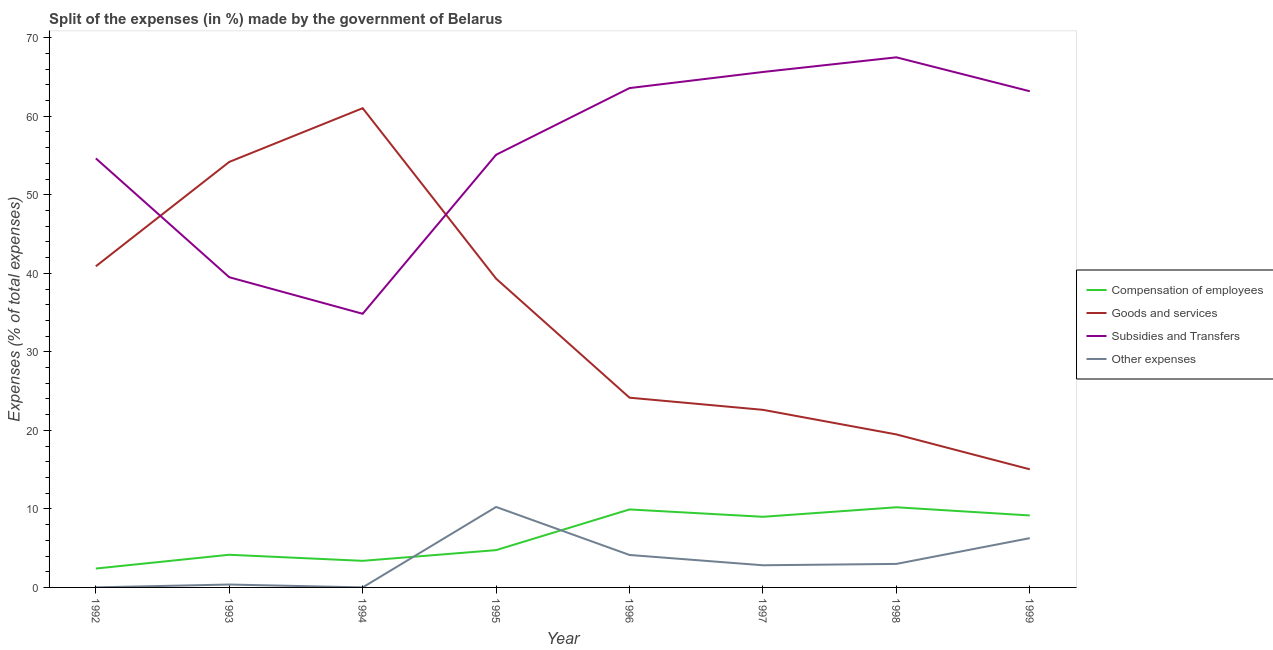How many different coloured lines are there?
Offer a terse response. 4. Does the line corresponding to percentage of amount spent on other expenses intersect with the line corresponding to percentage of amount spent on goods and services?
Provide a succinct answer. No. Is the number of lines equal to the number of legend labels?
Give a very brief answer. Yes. What is the percentage of amount spent on subsidies in 1998?
Provide a short and direct response. 67.51. Across all years, what is the maximum percentage of amount spent on compensation of employees?
Your answer should be compact. 10.21. Across all years, what is the minimum percentage of amount spent on other expenses?
Make the answer very short. 0. In which year was the percentage of amount spent on other expenses maximum?
Give a very brief answer. 1995. In which year was the percentage of amount spent on goods and services minimum?
Your answer should be very brief. 1999. What is the total percentage of amount spent on other expenses in the graph?
Your answer should be compact. 26.86. What is the difference between the percentage of amount spent on subsidies in 1996 and that in 1999?
Your answer should be very brief. 0.4. What is the difference between the percentage of amount spent on other expenses in 1999 and the percentage of amount spent on goods and services in 1996?
Give a very brief answer. -17.89. What is the average percentage of amount spent on subsidies per year?
Give a very brief answer. 55.5. In the year 1995, what is the difference between the percentage of amount spent on other expenses and percentage of amount spent on goods and services?
Your response must be concise. -29.07. In how many years, is the percentage of amount spent on subsidies greater than 26 %?
Offer a very short reply. 8. What is the ratio of the percentage of amount spent on other expenses in 1992 to that in 1997?
Provide a short and direct response. 0. Is the difference between the percentage of amount spent on subsidies in 1995 and 1998 greater than the difference between the percentage of amount spent on compensation of employees in 1995 and 1998?
Provide a short and direct response. No. What is the difference between the highest and the second highest percentage of amount spent on other expenses?
Provide a short and direct response. 3.97. What is the difference between the highest and the lowest percentage of amount spent on other expenses?
Make the answer very short. 10.24. Is it the case that in every year, the sum of the percentage of amount spent on subsidies and percentage of amount spent on compensation of employees is greater than the sum of percentage of amount spent on other expenses and percentage of amount spent on goods and services?
Your response must be concise. Yes. Is it the case that in every year, the sum of the percentage of amount spent on compensation of employees and percentage of amount spent on goods and services is greater than the percentage of amount spent on subsidies?
Give a very brief answer. No. Does the percentage of amount spent on goods and services monotonically increase over the years?
Your answer should be very brief. No. Is the percentage of amount spent on compensation of employees strictly greater than the percentage of amount spent on other expenses over the years?
Ensure brevity in your answer.  No. Is the percentage of amount spent on compensation of employees strictly less than the percentage of amount spent on other expenses over the years?
Make the answer very short. No. How many lines are there?
Keep it short and to the point. 4. Does the graph contain grids?
Your answer should be compact. No. Where does the legend appear in the graph?
Make the answer very short. Center right. How many legend labels are there?
Offer a terse response. 4. What is the title of the graph?
Your response must be concise. Split of the expenses (in %) made by the government of Belarus. Does "Quality Certification" appear as one of the legend labels in the graph?
Offer a terse response. No. What is the label or title of the Y-axis?
Your answer should be very brief. Expenses (% of total expenses). What is the Expenses (% of total expenses) in Compensation of employees in 1992?
Your response must be concise. 2.41. What is the Expenses (% of total expenses) of Goods and services in 1992?
Your response must be concise. 40.89. What is the Expenses (% of total expenses) of Subsidies and Transfers in 1992?
Your answer should be compact. 54.64. What is the Expenses (% of total expenses) of Other expenses in 1992?
Your answer should be very brief. 0.01. What is the Expenses (% of total expenses) of Compensation of employees in 1993?
Provide a succinct answer. 4.16. What is the Expenses (% of total expenses) in Goods and services in 1993?
Give a very brief answer. 54.19. What is the Expenses (% of total expenses) in Subsidies and Transfers in 1993?
Provide a short and direct response. 39.5. What is the Expenses (% of total expenses) of Other expenses in 1993?
Your answer should be very brief. 0.37. What is the Expenses (% of total expenses) in Compensation of employees in 1994?
Your response must be concise. 3.39. What is the Expenses (% of total expenses) in Goods and services in 1994?
Your response must be concise. 61.03. What is the Expenses (% of total expenses) of Subsidies and Transfers in 1994?
Your answer should be very brief. 34.85. What is the Expenses (% of total expenses) of Other expenses in 1994?
Your answer should be compact. 0. What is the Expenses (% of total expenses) in Compensation of employees in 1995?
Offer a very short reply. 4.75. What is the Expenses (% of total expenses) of Goods and services in 1995?
Provide a succinct answer. 39.32. What is the Expenses (% of total expenses) in Subsidies and Transfers in 1995?
Your response must be concise. 55.1. What is the Expenses (% of total expenses) in Other expenses in 1995?
Your response must be concise. 10.25. What is the Expenses (% of total expenses) of Compensation of employees in 1996?
Your response must be concise. 9.93. What is the Expenses (% of total expenses) of Goods and services in 1996?
Your answer should be very brief. 24.16. What is the Expenses (% of total expenses) of Subsidies and Transfers in 1996?
Your response must be concise. 63.59. What is the Expenses (% of total expenses) of Other expenses in 1996?
Give a very brief answer. 4.13. What is the Expenses (% of total expenses) of Compensation of employees in 1997?
Offer a very short reply. 8.99. What is the Expenses (% of total expenses) of Goods and services in 1997?
Your answer should be compact. 22.62. What is the Expenses (% of total expenses) of Subsidies and Transfers in 1997?
Keep it short and to the point. 65.64. What is the Expenses (% of total expenses) of Other expenses in 1997?
Give a very brief answer. 2.82. What is the Expenses (% of total expenses) of Compensation of employees in 1998?
Offer a very short reply. 10.21. What is the Expenses (% of total expenses) of Goods and services in 1998?
Offer a terse response. 19.49. What is the Expenses (% of total expenses) of Subsidies and Transfers in 1998?
Give a very brief answer. 67.51. What is the Expenses (% of total expenses) of Other expenses in 1998?
Ensure brevity in your answer.  2.99. What is the Expenses (% of total expenses) of Compensation of employees in 1999?
Provide a short and direct response. 9.17. What is the Expenses (% of total expenses) in Goods and services in 1999?
Your answer should be very brief. 15.04. What is the Expenses (% of total expenses) in Subsidies and Transfers in 1999?
Your answer should be compact. 63.19. What is the Expenses (% of total expenses) of Other expenses in 1999?
Your response must be concise. 6.28. Across all years, what is the maximum Expenses (% of total expenses) of Compensation of employees?
Give a very brief answer. 10.21. Across all years, what is the maximum Expenses (% of total expenses) of Goods and services?
Your answer should be very brief. 61.03. Across all years, what is the maximum Expenses (% of total expenses) in Subsidies and Transfers?
Ensure brevity in your answer.  67.51. Across all years, what is the maximum Expenses (% of total expenses) of Other expenses?
Make the answer very short. 10.25. Across all years, what is the minimum Expenses (% of total expenses) of Compensation of employees?
Ensure brevity in your answer.  2.41. Across all years, what is the minimum Expenses (% of total expenses) in Goods and services?
Ensure brevity in your answer.  15.04. Across all years, what is the minimum Expenses (% of total expenses) of Subsidies and Transfers?
Your answer should be very brief. 34.85. Across all years, what is the minimum Expenses (% of total expenses) in Other expenses?
Ensure brevity in your answer.  0. What is the total Expenses (% of total expenses) in Compensation of employees in the graph?
Give a very brief answer. 53. What is the total Expenses (% of total expenses) of Goods and services in the graph?
Give a very brief answer. 276.73. What is the total Expenses (% of total expenses) in Subsidies and Transfers in the graph?
Provide a short and direct response. 444.02. What is the total Expenses (% of total expenses) of Other expenses in the graph?
Make the answer very short. 26.86. What is the difference between the Expenses (% of total expenses) in Compensation of employees in 1992 and that in 1993?
Provide a succinct answer. -1.75. What is the difference between the Expenses (% of total expenses) of Goods and services in 1992 and that in 1993?
Make the answer very short. -13.29. What is the difference between the Expenses (% of total expenses) in Subsidies and Transfers in 1992 and that in 1993?
Provide a succinct answer. 15.14. What is the difference between the Expenses (% of total expenses) in Other expenses in 1992 and that in 1993?
Provide a succinct answer. -0.36. What is the difference between the Expenses (% of total expenses) of Compensation of employees in 1992 and that in 1994?
Ensure brevity in your answer.  -0.98. What is the difference between the Expenses (% of total expenses) of Goods and services in 1992 and that in 1994?
Your response must be concise. -20.14. What is the difference between the Expenses (% of total expenses) of Subsidies and Transfers in 1992 and that in 1994?
Ensure brevity in your answer.  19.79. What is the difference between the Expenses (% of total expenses) of Other expenses in 1992 and that in 1994?
Your response must be concise. 0.01. What is the difference between the Expenses (% of total expenses) in Compensation of employees in 1992 and that in 1995?
Your answer should be compact. -2.35. What is the difference between the Expenses (% of total expenses) of Goods and services in 1992 and that in 1995?
Keep it short and to the point. 1.57. What is the difference between the Expenses (% of total expenses) of Subsidies and Transfers in 1992 and that in 1995?
Your response must be concise. -0.46. What is the difference between the Expenses (% of total expenses) in Other expenses in 1992 and that in 1995?
Make the answer very short. -10.24. What is the difference between the Expenses (% of total expenses) in Compensation of employees in 1992 and that in 1996?
Your answer should be compact. -7.53. What is the difference between the Expenses (% of total expenses) of Goods and services in 1992 and that in 1996?
Ensure brevity in your answer.  16.73. What is the difference between the Expenses (% of total expenses) in Subsidies and Transfers in 1992 and that in 1996?
Provide a short and direct response. -8.95. What is the difference between the Expenses (% of total expenses) in Other expenses in 1992 and that in 1996?
Keep it short and to the point. -4.12. What is the difference between the Expenses (% of total expenses) of Compensation of employees in 1992 and that in 1997?
Make the answer very short. -6.59. What is the difference between the Expenses (% of total expenses) in Goods and services in 1992 and that in 1997?
Ensure brevity in your answer.  18.28. What is the difference between the Expenses (% of total expenses) of Subsidies and Transfers in 1992 and that in 1997?
Provide a short and direct response. -11. What is the difference between the Expenses (% of total expenses) in Other expenses in 1992 and that in 1997?
Your response must be concise. -2.81. What is the difference between the Expenses (% of total expenses) of Compensation of employees in 1992 and that in 1998?
Keep it short and to the point. -7.8. What is the difference between the Expenses (% of total expenses) of Goods and services in 1992 and that in 1998?
Provide a short and direct response. 21.41. What is the difference between the Expenses (% of total expenses) in Subsidies and Transfers in 1992 and that in 1998?
Provide a short and direct response. -12.87. What is the difference between the Expenses (% of total expenses) of Other expenses in 1992 and that in 1998?
Make the answer very short. -2.99. What is the difference between the Expenses (% of total expenses) in Compensation of employees in 1992 and that in 1999?
Make the answer very short. -6.76. What is the difference between the Expenses (% of total expenses) in Goods and services in 1992 and that in 1999?
Your answer should be very brief. 25.85. What is the difference between the Expenses (% of total expenses) of Subsidies and Transfers in 1992 and that in 1999?
Keep it short and to the point. -8.55. What is the difference between the Expenses (% of total expenses) of Other expenses in 1992 and that in 1999?
Provide a short and direct response. -6.27. What is the difference between the Expenses (% of total expenses) in Compensation of employees in 1993 and that in 1994?
Offer a very short reply. 0.77. What is the difference between the Expenses (% of total expenses) in Goods and services in 1993 and that in 1994?
Provide a short and direct response. -6.84. What is the difference between the Expenses (% of total expenses) of Subsidies and Transfers in 1993 and that in 1994?
Offer a very short reply. 4.65. What is the difference between the Expenses (% of total expenses) of Other expenses in 1993 and that in 1994?
Your answer should be very brief. 0.37. What is the difference between the Expenses (% of total expenses) of Compensation of employees in 1993 and that in 1995?
Offer a terse response. -0.59. What is the difference between the Expenses (% of total expenses) in Goods and services in 1993 and that in 1995?
Keep it short and to the point. 14.87. What is the difference between the Expenses (% of total expenses) in Subsidies and Transfers in 1993 and that in 1995?
Provide a short and direct response. -15.6. What is the difference between the Expenses (% of total expenses) of Other expenses in 1993 and that in 1995?
Offer a terse response. -9.88. What is the difference between the Expenses (% of total expenses) in Compensation of employees in 1993 and that in 1996?
Provide a succinct answer. -5.77. What is the difference between the Expenses (% of total expenses) of Goods and services in 1993 and that in 1996?
Offer a very short reply. 30.03. What is the difference between the Expenses (% of total expenses) in Subsidies and Transfers in 1993 and that in 1996?
Give a very brief answer. -24.09. What is the difference between the Expenses (% of total expenses) of Other expenses in 1993 and that in 1996?
Offer a very short reply. -3.76. What is the difference between the Expenses (% of total expenses) in Compensation of employees in 1993 and that in 1997?
Offer a very short reply. -4.83. What is the difference between the Expenses (% of total expenses) of Goods and services in 1993 and that in 1997?
Offer a very short reply. 31.57. What is the difference between the Expenses (% of total expenses) of Subsidies and Transfers in 1993 and that in 1997?
Offer a very short reply. -26.14. What is the difference between the Expenses (% of total expenses) in Other expenses in 1993 and that in 1997?
Keep it short and to the point. -2.45. What is the difference between the Expenses (% of total expenses) in Compensation of employees in 1993 and that in 1998?
Your response must be concise. -6.05. What is the difference between the Expenses (% of total expenses) in Goods and services in 1993 and that in 1998?
Offer a very short reply. 34.7. What is the difference between the Expenses (% of total expenses) in Subsidies and Transfers in 1993 and that in 1998?
Your answer should be very brief. -28. What is the difference between the Expenses (% of total expenses) of Other expenses in 1993 and that in 1998?
Provide a short and direct response. -2.63. What is the difference between the Expenses (% of total expenses) of Compensation of employees in 1993 and that in 1999?
Your answer should be very brief. -5.01. What is the difference between the Expenses (% of total expenses) of Goods and services in 1993 and that in 1999?
Your answer should be very brief. 39.15. What is the difference between the Expenses (% of total expenses) of Subsidies and Transfers in 1993 and that in 1999?
Your response must be concise. -23.68. What is the difference between the Expenses (% of total expenses) in Other expenses in 1993 and that in 1999?
Keep it short and to the point. -5.91. What is the difference between the Expenses (% of total expenses) in Compensation of employees in 1994 and that in 1995?
Give a very brief answer. -1.36. What is the difference between the Expenses (% of total expenses) of Goods and services in 1994 and that in 1995?
Ensure brevity in your answer.  21.71. What is the difference between the Expenses (% of total expenses) of Subsidies and Transfers in 1994 and that in 1995?
Your response must be concise. -20.25. What is the difference between the Expenses (% of total expenses) of Other expenses in 1994 and that in 1995?
Provide a short and direct response. -10.24. What is the difference between the Expenses (% of total expenses) in Compensation of employees in 1994 and that in 1996?
Your response must be concise. -6.54. What is the difference between the Expenses (% of total expenses) in Goods and services in 1994 and that in 1996?
Provide a short and direct response. 36.87. What is the difference between the Expenses (% of total expenses) of Subsidies and Transfers in 1994 and that in 1996?
Make the answer very short. -28.74. What is the difference between the Expenses (% of total expenses) of Other expenses in 1994 and that in 1996?
Give a very brief answer. -4.13. What is the difference between the Expenses (% of total expenses) in Compensation of employees in 1994 and that in 1997?
Give a very brief answer. -5.61. What is the difference between the Expenses (% of total expenses) in Goods and services in 1994 and that in 1997?
Make the answer very short. 38.41. What is the difference between the Expenses (% of total expenses) in Subsidies and Transfers in 1994 and that in 1997?
Give a very brief answer. -30.79. What is the difference between the Expenses (% of total expenses) in Other expenses in 1994 and that in 1997?
Your response must be concise. -2.82. What is the difference between the Expenses (% of total expenses) in Compensation of employees in 1994 and that in 1998?
Offer a very short reply. -6.82. What is the difference between the Expenses (% of total expenses) of Goods and services in 1994 and that in 1998?
Ensure brevity in your answer.  41.54. What is the difference between the Expenses (% of total expenses) of Subsidies and Transfers in 1994 and that in 1998?
Offer a very short reply. -32.66. What is the difference between the Expenses (% of total expenses) in Other expenses in 1994 and that in 1998?
Provide a short and direct response. -2.99. What is the difference between the Expenses (% of total expenses) in Compensation of employees in 1994 and that in 1999?
Keep it short and to the point. -5.78. What is the difference between the Expenses (% of total expenses) of Goods and services in 1994 and that in 1999?
Offer a terse response. 45.99. What is the difference between the Expenses (% of total expenses) in Subsidies and Transfers in 1994 and that in 1999?
Offer a terse response. -28.34. What is the difference between the Expenses (% of total expenses) of Other expenses in 1994 and that in 1999?
Keep it short and to the point. -6.27. What is the difference between the Expenses (% of total expenses) in Compensation of employees in 1995 and that in 1996?
Ensure brevity in your answer.  -5.18. What is the difference between the Expenses (% of total expenses) in Goods and services in 1995 and that in 1996?
Ensure brevity in your answer.  15.16. What is the difference between the Expenses (% of total expenses) of Subsidies and Transfers in 1995 and that in 1996?
Ensure brevity in your answer.  -8.49. What is the difference between the Expenses (% of total expenses) of Other expenses in 1995 and that in 1996?
Offer a terse response. 6.11. What is the difference between the Expenses (% of total expenses) of Compensation of employees in 1995 and that in 1997?
Give a very brief answer. -4.24. What is the difference between the Expenses (% of total expenses) of Goods and services in 1995 and that in 1997?
Offer a very short reply. 16.7. What is the difference between the Expenses (% of total expenses) of Subsidies and Transfers in 1995 and that in 1997?
Give a very brief answer. -10.54. What is the difference between the Expenses (% of total expenses) of Other expenses in 1995 and that in 1997?
Keep it short and to the point. 7.43. What is the difference between the Expenses (% of total expenses) of Compensation of employees in 1995 and that in 1998?
Your answer should be very brief. -5.46. What is the difference between the Expenses (% of total expenses) in Goods and services in 1995 and that in 1998?
Offer a terse response. 19.83. What is the difference between the Expenses (% of total expenses) of Subsidies and Transfers in 1995 and that in 1998?
Make the answer very short. -12.41. What is the difference between the Expenses (% of total expenses) in Other expenses in 1995 and that in 1998?
Make the answer very short. 7.25. What is the difference between the Expenses (% of total expenses) of Compensation of employees in 1995 and that in 1999?
Offer a very short reply. -4.41. What is the difference between the Expenses (% of total expenses) of Goods and services in 1995 and that in 1999?
Make the answer very short. 24.28. What is the difference between the Expenses (% of total expenses) in Subsidies and Transfers in 1995 and that in 1999?
Offer a very short reply. -8.09. What is the difference between the Expenses (% of total expenses) of Other expenses in 1995 and that in 1999?
Your answer should be very brief. 3.97. What is the difference between the Expenses (% of total expenses) of Compensation of employees in 1996 and that in 1997?
Offer a very short reply. 0.94. What is the difference between the Expenses (% of total expenses) of Goods and services in 1996 and that in 1997?
Your answer should be compact. 1.55. What is the difference between the Expenses (% of total expenses) of Subsidies and Transfers in 1996 and that in 1997?
Your answer should be very brief. -2.05. What is the difference between the Expenses (% of total expenses) in Other expenses in 1996 and that in 1997?
Your answer should be compact. 1.31. What is the difference between the Expenses (% of total expenses) of Compensation of employees in 1996 and that in 1998?
Keep it short and to the point. -0.28. What is the difference between the Expenses (% of total expenses) in Goods and services in 1996 and that in 1998?
Your answer should be compact. 4.68. What is the difference between the Expenses (% of total expenses) of Subsidies and Transfers in 1996 and that in 1998?
Offer a very short reply. -3.92. What is the difference between the Expenses (% of total expenses) in Other expenses in 1996 and that in 1998?
Give a very brief answer. 1.14. What is the difference between the Expenses (% of total expenses) in Compensation of employees in 1996 and that in 1999?
Provide a short and direct response. 0.77. What is the difference between the Expenses (% of total expenses) in Goods and services in 1996 and that in 1999?
Make the answer very short. 9.12. What is the difference between the Expenses (% of total expenses) of Subsidies and Transfers in 1996 and that in 1999?
Give a very brief answer. 0.4. What is the difference between the Expenses (% of total expenses) of Other expenses in 1996 and that in 1999?
Make the answer very short. -2.14. What is the difference between the Expenses (% of total expenses) of Compensation of employees in 1997 and that in 1998?
Provide a succinct answer. -1.21. What is the difference between the Expenses (% of total expenses) of Goods and services in 1997 and that in 1998?
Make the answer very short. 3.13. What is the difference between the Expenses (% of total expenses) in Subsidies and Transfers in 1997 and that in 1998?
Your answer should be compact. -1.86. What is the difference between the Expenses (% of total expenses) of Other expenses in 1997 and that in 1998?
Keep it short and to the point. -0.17. What is the difference between the Expenses (% of total expenses) in Compensation of employees in 1997 and that in 1999?
Keep it short and to the point. -0.17. What is the difference between the Expenses (% of total expenses) of Goods and services in 1997 and that in 1999?
Give a very brief answer. 7.58. What is the difference between the Expenses (% of total expenses) of Subsidies and Transfers in 1997 and that in 1999?
Provide a succinct answer. 2.46. What is the difference between the Expenses (% of total expenses) of Other expenses in 1997 and that in 1999?
Give a very brief answer. -3.45. What is the difference between the Expenses (% of total expenses) of Compensation of employees in 1998 and that in 1999?
Your response must be concise. 1.04. What is the difference between the Expenses (% of total expenses) in Goods and services in 1998 and that in 1999?
Ensure brevity in your answer.  4.44. What is the difference between the Expenses (% of total expenses) of Subsidies and Transfers in 1998 and that in 1999?
Your answer should be compact. 4.32. What is the difference between the Expenses (% of total expenses) in Other expenses in 1998 and that in 1999?
Your response must be concise. -3.28. What is the difference between the Expenses (% of total expenses) of Compensation of employees in 1992 and the Expenses (% of total expenses) of Goods and services in 1993?
Provide a short and direct response. -51.78. What is the difference between the Expenses (% of total expenses) of Compensation of employees in 1992 and the Expenses (% of total expenses) of Subsidies and Transfers in 1993?
Offer a terse response. -37.1. What is the difference between the Expenses (% of total expenses) in Compensation of employees in 1992 and the Expenses (% of total expenses) in Other expenses in 1993?
Your response must be concise. 2.04. What is the difference between the Expenses (% of total expenses) in Goods and services in 1992 and the Expenses (% of total expenses) in Subsidies and Transfers in 1993?
Offer a terse response. 1.39. What is the difference between the Expenses (% of total expenses) of Goods and services in 1992 and the Expenses (% of total expenses) of Other expenses in 1993?
Provide a short and direct response. 40.52. What is the difference between the Expenses (% of total expenses) in Subsidies and Transfers in 1992 and the Expenses (% of total expenses) in Other expenses in 1993?
Your answer should be very brief. 54.27. What is the difference between the Expenses (% of total expenses) of Compensation of employees in 1992 and the Expenses (% of total expenses) of Goods and services in 1994?
Provide a short and direct response. -58.62. What is the difference between the Expenses (% of total expenses) in Compensation of employees in 1992 and the Expenses (% of total expenses) in Subsidies and Transfers in 1994?
Your answer should be compact. -32.44. What is the difference between the Expenses (% of total expenses) of Compensation of employees in 1992 and the Expenses (% of total expenses) of Other expenses in 1994?
Offer a terse response. 2.4. What is the difference between the Expenses (% of total expenses) of Goods and services in 1992 and the Expenses (% of total expenses) of Subsidies and Transfers in 1994?
Provide a short and direct response. 6.05. What is the difference between the Expenses (% of total expenses) of Goods and services in 1992 and the Expenses (% of total expenses) of Other expenses in 1994?
Offer a very short reply. 40.89. What is the difference between the Expenses (% of total expenses) of Subsidies and Transfers in 1992 and the Expenses (% of total expenses) of Other expenses in 1994?
Give a very brief answer. 54.63. What is the difference between the Expenses (% of total expenses) in Compensation of employees in 1992 and the Expenses (% of total expenses) in Goods and services in 1995?
Ensure brevity in your answer.  -36.91. What is the difference between the Expenses (% of total expenses) in Compensation of employees in 1992 and the Expenses (% of total expenses) in Subsidies and Transfers in 1995?
Keep it short and to the point. -52.7. What is the difference between the Expenses (% of total expenses) in Compensation of employees in 1992 and the Expenses (% of total expenses) in Other expenses in 1995?
Your response must be concise. -7.84. What is the difference between the Expenses (% of total expenses) in Goods and services in 1992 and the Expenses (% of total expenses) in Subsidies and Transfers in 1995?
Your response must be concise. -14.21. What is the difference between the Expenses (% of total expenses) in Goods and services in 1992 and the Expenses (% of total expenses) in Other expenses in 1995?
Offer a terse response. 30.65. What is the difference between the Expenses (% of total expenses) of Subsidies and Transfers in 1992 and the Expenses (% of total expenses) of Other expenses in 1995?
Provide a succinct answer. 44.39. What is the difference between the Expenses (% of total expenses) of Compensation of employees in 1992 and the Expenses (% of total expenses) of Goods and services in 1996?
Offer a very short reply. -21.76. What is the difference between the Expenses (% of total expenses) in Compensation of employees in 1992 and the Expenses (% of total expenses) in Subsidies and Transfers in 1996?
Keep it short and to the point. -61.19. What is the difference between the Expenses (% of total expenses) of Compensation of employees in 1992 and the Expenses (% of total expenses) of Other expenses in 1996?
Provide a succinct answer. -1.73. What is the difference between the Expenses (% of total expenses) in Goods and services in 1992 and the Expenses (% of total expenses) in Subsidies and Transfers in 1996?
Your answer should be compact. -22.7. What is the difference between the Expenses (% of total expenses) of Goods and services in 1992 and the Expenses (% of total expenses) of Other expenses in 1996?
Offer a very short reply. 36.76. What is the difference between the Expenses (% of total expenses) in Subsidies and Transfers in 1992 and the Expenses (% of total expenses) in Other expenses in 1996?
Provide a succinct answer. 50.51. What is the difference between the Expenses (% of total expenses) of Compensation of employees in 1992 and the Expenses (% of total expenses) of Goods and services in 1997?
Offer a terse response. -20.21. What is the difference between the Expenses (% of total expenses) in Compensation of employees in 1992 and the Expenses (% of total expenses) in Subsidies and Transfers in 1997?
Ensure brevity in your answer.  -63.24. What is the difference between the Expenses (% of total expenses) of Compensation of employees in 1992 and the Expenses (% of total expenses) of Other expenses in 1997?
Provide a succinct answer. -0.42. What is the difference between the Expenses (% of total expenses) in Goods and services in 1992 and the Expenses (% of total expenses) in Subsidies and Transfers in 1997?
Ensure brevity in your answer.  -24.75. What is the difference between the Expenses (% of total expenses) of Goods and services in 1992 and the Expenses (% of total expenses) of Other expenses in 1997?
Make the answer very short. 38.07. What is the difference between the Expenses (% of total expenses) in Subsidies and Transfers in 1992 and the Expenses (% of total expenses) in Other expenses in 1997?
Make the answer very short. 51.82. What is the difference between the Expenses (% of total expenses) of Compensation of employees in 1992 and the Expenses (% of total expenses) of Goods and services in 1998?
Give a very brief answer. -17.08. What is the difference between the Expenses (% of total expenses) of Compensation of employees in 1992 and the Expenses (% of total expenses) of Subsidies and Transfers in 1998?
Your answer should be compact. -65.1. What is the difference between the Expenses (% of total expenses) of Compensation of employees in 1992 and the Expenses (% of total expenses) of Other expenses in 1998?
Your answer should be compact. -0.59. What is the difference between the Expenses (% of total expenses) of Goods and services in 1992 and the Expenses (% of total expenses) of Subsidies and Transfers in 1998?
Make the answer very short. -26.61. What is the difference between the Expenses (% of total expenses) of Goods and services in 1992 and the Expenses (% of total expenses) of Other expenses in 1998?
Keep it short and to the point. 37.9. What is the difference between the Expenses (% of total expenses) in Subsidies and Transfers in 1992 and the Expenses (% of total expenses) in Other expenses in 1998?
Ensure brevity in your answer.  51.64. What is the difference between the Expenses (% of total expenses) of Compensation of employees in 1992 and the Expenses (% of total expenses) of Goods and services in 1999?
Your answer should be compact. -12.64. What is the difference between the Expenses (% of total expenses) of Compensation of employees in 1992 and the Expenses (% of total expenses) of Subsidies and Transfers in 1999?
Your answer should be compact. -60.78. What is the difference between the Expenses (% of total expenses) of Compensation of employees in 1992 and the Expenses (% of total expenses) of Other expenses in 1999?
Ensure brevity in your answer.  -3.87. What is the difference between the Expenses (% of total expenses) of Goods and services in 1992 and the Expenses (% of total expenses) of Subsidies and Transfers in 1999?
Make the answer very short. -22.29. What is the difference between the Expenses (% of total expenses) of Goods and services in 1992 and the Expenses (% of total expenses) of Other expenses in 1999?
Give a very brief answer. 34.62. What is the difference between the Expenses (% of total expenses) in Subsidies and Transfers in 1992 and the Expenses (% of total expenses) in Other expenses in 1999?
Ensure brevity in your answer.  48.36. What is the difference between the Expenses (% of total expenses) in Compensation of employees in 1993 and the Expenses (% of total expenses) in Goods and services in 1994?
Your answer should be very brief. -56.87. What is the difference between the Expenses (% of total expenses) in Compensation of employees in 1993 and the Expenses (% of total expenses) in Subsidies and Transfers in 1994?
Your answer should be very brief. -30.69. What is the difference between the Expenses (% of total expenses) in Compensation of employees in 1993 and the Expenses (% of total expenses) in Other expenses in 1994?
Your answer should be compact. 4.16. What is the difference between the Expenses (% of total expenses) of Goods and services in 1993 and the Expenses (% of total expenses) of Subsidies and Transfers in 1994?
Provide a short and direct response. 19.34. What is the difference between the Expenses (% of total expenses) in Goods and services in 1993 and the Expenses (% of total expenses) in Other expenses in 1994?
Offer a terse response. 54.18. What is the difference between the Expenses (% of total expenses) of Subsidies and Transfers in 1993 and the Expenses (% of total expenses) of Other expenses in 1994?
Offer a terse response. 39.5. What is the difference between the Expenses (% of total expenses) in Compensation of employees in 1993 and the Expenses (% of total expenses) in Goods and services in 1995?
Make the answer very short. -35.16. What is the difference between the Expenses (% of total expenses) of Compensation of employees in 1993 and the Expenses (% of total expenses) of Subsidies and Transfers in 1995?
Give a very brief answer. -50.94. What is the difference between the Expenses (% of total expenses) of Compensation of employees in 1993 and the Expenses (% of total expenses) of Other expenses in 1995?
Offer a terse response. -6.09. What is the difference between the Expenses (% of total expenses) in Goods and services in 1993 and the Expenses (% of total expenses) in Subsidies and Transfers in 1995?
Provide a succinct answer. -0.91. What is the difference between the Expenses (% of total expenses) of Goods and services in 1993 and the Expenses (% of total expenses) of Other expenses in 1995?
Provide a succinct answer. 43.94. What is the difference between the Expenses (% of total expenses) of Subsidies and Transfers in 1993 and the Expenses (% of total expenses) of Other expenses in 1995?
Provide a short and direct response. 29.26. What is the difference between the Expenses (% of total expenses) of Compensation of employees in 1993 and the Expenses (% of total expenses) of Goods and services in 1996?
Keep it short and to the point. -20. What is the difference between the Expenses (% of total expenses) of Compensation of employees in 1993 and the Expenses (% of total expenses) of Subsidies and Transfers in 1996?
Keep it short and to the point. -59.43. What is the difference between the Expenses (% of total expenses) of Compensation of employees in 1993 and the Expenses (% of total expenses) of Other expenses in 1996?
Give a very brief answer. 0.03. What is the difference between the Expenses (% of total expenses) of Goods and services in 1993 and the Expenses (% of total expenses) of Subsidies and Transfers in 1996?
Ensure brevity in your answer.  -9.4. What is the difference between the Expenses (% of total expenses) of Goods and services in 1993 and the Expenses (% of total expenses) of Other expenses in 1996?
Provide a short and direct response. 50.05. What is the difference between the Expenses (% of total expenses) of Subsidies and Transfers in 1993 and the Expenses (% of total expenses) of Other expenses in 1996?
Your response must be concise. 35.37. What is the difference between the Expenses (% of total expenses) in Compensation of employees in 1993 and the Expenses (% of total expenses) in Goods and services in 1997?
Provide a succinct answer. -18.46. What is the difference between the Expenses (% of total expenses) of Compensation of employees in 1993 and the Expenses (% of total expenses) of Subsidies and Transfers in 1997?
Your response must be concise. -61.48. What is the difference between the Expenses (% of total expenses) in Compensation of employees in 1993 and the Expenses (% of total expenses) in Other expenses in 1997?
Your answer should be compact. 1.34. What is the difference between the Expenses (% of total expenses) in Goods and services in 1993 and the Expenses (% of total expenses) in Subsidies and Transfers in 1997?
Ensure brevity in your answer.  -11.45. What is the difference between the Expenses (% of total expenses) of Goods and services in 1993 and the Expenses (% of total expenses) of Other expenses in 1997?
Provide a short and direct response. 51.37. What is the difference between the Expenses (% of total expenses) in Subsidies and Transfers in 1993 and the Expenses (% of total expenses) in Other expenses in 1997?
Provide a succinct answer. 36.68. What is the difference between the Expenses (% of total expenses) of Compensation of employees in 1993 and the Expenses (% of total expenses) of Goods and services in 1998?
Keep it short and to the point. -15.33. What is the difference between the Expenses (% of total expenses) in Compensation of employees in 1993 and the Expenses (% of total expenses) in Subsidies and Transfers in 1998?
Keep it short and to the point. -63.35. What is the difference between the Expenses (% of total expenses) in Compensation of employees in 1993 and the Expenses (% of total expenses) in Other expenses in 1998?
Keep it short and to the point. 1.16. What is the difference between the Expenses (% of total expenses) in Goods and services in 1993 and the Expenses (% of total expenses) in Subsidies and Transfers in 1998?
Your answer should be compact. -13.32. What is the difference between the Expenses (% of total expenses) in Goods and services in 1993 and the Expenses (% of total expenses) in Other expenses in 1998?
Give a very brief answer. 51.19. What is the difference between the Expenses (% of total expenses) of Subsidies and Transfers in 1993 and the Expenses (% of total expenses) of Other expenses in 1998?
Offer a terse response. 36.51. What is the difference between the Expenses (% of total expenses) of Compensation of employees in 1993 and the Expenses (% of total expenses) of Goods and services in 1999?
Provide a short and direct response. -10.88. What is the difference between the Expenses (% of total expenses) in Compensation of employees in 1993 and the Expenses (% of total expenses) in Subsidies and Transfers in 1999?
Your answer should be compact. -59.03. What is the difference between the Expenses (% of total expenses) of Compensation of employees in 1993 and the Expenses (% of total expenses) of Other expenses in 1999?
Offer a terse response. -2.12. What is the difference between the Expenses (% of total expenses) in Goods and services in 1993 and the Expenses (% of total expenses) in Subsidies and Transfers in 1999?
Your answer should be compact. -9. What is the difference between the Expenses (% of total expenses) in Goods and services in 1993 and the Expenses (% of total expenses) in Other expenses in 1999?
Give a very brief answer. 47.91. What is the difference between the Expenses (% of total expenses) of Subsidies and Transfers in 1993 and the Expenses (% of total expenses) of Other expenses in 1999?
Make the answer very short. 33.23. What is the difference between the Expenses (% of total expenses) of Compensation of employees in 1994 and the Expenses (% of total expenses) of Goods and services in 1995?
Ensure brevity in your answer.  -35.93. What is the difference between the Expenses (% of total expenses) of Compensation of employees in 1994 and the Expenses (% of total expenses) of Subsidies and Transfers in 1995?
Provide a short and direct response. -51.71. What is the difference between the Expenses (% of total expenses) of Compensation of employees in 1994 and the Expenses (% of total expenses) of Other expenses in 1995?
Your answer should be compact. -6.86. What is the difference between the Expenses (% of total expenses) in Goods and services in 1994 and the Expenses (% of total expenses) in Subsidies and Transfers in 1995?
Provide a short and direct response. 5.93. What is the difference between the Expenses (% of total expenses) of Goods and services in 1994 and the Expenses (% of total expenses) of Other expenses in 1995?
Keep it short and to the point. 50.78. What is the difference between the Expenses (% of total expenses) in Subsidies and Transfers in 1994 and the Expenses (% of total expenses) in Other expenses in 1995?
Make the answer very short. 24.6. What is the difference between the Expenses (% of total expenses) of Compensation of employees in 1994 and the Expenses (% of total expenses) of Goods and services in 1996?
Offer a terse response. -20.78. What is the difference between the Expenses (% of total expenses) in Compensation of employees in 1994 and the Expenses (% of total expenses) in Subsidies and Transfers in 1996?
Provide a short and direct response. -60.2. What is the difference between the Expenses (% of total expenses) in Compensation of employees in 1994 and the Expenses (% of total expenses) in Other expenses in 1996?
Your answer should be very brief. -0.75. What is the difference between the Expenses (% of total expenses) of Goods and services in 1994 and the Expenses (% of total expenses) of Subsidies and Transfers in 1996?
Ensure brevity in your answer.  -2.56. What is the difference between the Expenses (% of total expenses) of Goods and services in 1994 and the Expenses (% of total expenses) of Other expenses in 1996?
Your response must be concise. 56.9. What is the difference between the Expenses (% of total expenses) of Subsidies and Transfers in 1994 and the Expenses (% of total expenses) of Other expenses in 1996?
Offer a very short reply. 30.71. What is the difference between the Expenses (% of total expenses) of Compensation of employees in 1994 and the Expenses (% of total expenses) of Goods and services in 1997?
Offer a terse response. -19.23. What is the difference between the Expenses (% of total expenses) in Compensation of employees in 1994 and the Expenses (% of total expenses) in Subsidies and Transfers in 1997?
Ensure brevity in your answer.  -62.26. What is the difference between the Expenses (% of total expenses) of Compensation of employees in 1994 and the Expenses (% of total expenses) of Other expenses in 1997?
Provide a short and direct response. 0.56. What is the difference between the Expenses (% of total expenses) of Goods and services in 1994 and the Expenses (% of total expenses) of Subsidies and Transfers in 1997?
Offer a terse response. -4.61. What is the difference between the Expenses (% of total expenses) in Goods and services in 1994 and the Expenses (% of total expenses) in Other expenses in 1997?
Offer a very short reply. 58.21. What is the difference between the Expenses (% of total expenses) in Subsidies and Transfers in 1994 and the Expenses (% of total expenses) in Other expenses in 1997?
Keep it short and to the point. 32.03. What is the difference between the Expenses (% of total expenses) of Compensation of employees in 1994 and the Expenses (% of total expenses) of Goods and services in 1998?
Provide a succinct answer. -16.1. What is the difference between the Expenses (% of total expenses) in Compensation of employees in 1994 and the Expenses (% of total expenses) in Subsidies and Transfers in 1998?
Offer a very short reply. -64.12. What is the difference between the Expenses (% of total expenses) in Compensation of employees in 1994 and the Expenses (% of total expenses) in Other expenses in 1998?
Your answer should be very brief. 0.39. What is the difference between the Expenses (% of total expenses) in Goods and services in 1994 and the Expenses (% of total expenses) in Subsidies and Transfers in 1998?
Make the answer very short. -6.48. What is the difference between the Expenses (% of total expenses) in Goods and services in 1994 and the Expenses (% of total expenses) in Other expenses in 1998?
Give a very brief answer. 58.03. What is the difference between the Expenses (% of total expenses) in Subsidies and Transfers in 1994 and the Expenses (% of total expenses) in Other expenses in 1998?
Your answer should be very brief. 31.85. What is the difference between the Expenses (% of total expenses) in Compensation of employees in 1994 and the Expenses (% of total expenses) in Goods and services in 1999?
Your answer should be compact. -11.65. What is the difference between the Expenses (% of total expenses) in Compensation of employees in 1994 and the Expenses (% of total expenses) in Subsidies and Transfers in 1999?
Keep it short and to the point. -59.8. What is the difference between the Expenses (% of total expenses) in Compensation of employees in 1994 and the Expenses (% of total expenses) in Other expenses in 1999?
Give a very brief answer. -2.89. What is the difference between the Expenses (% of total expenses) of Goods and services in 1994 and the Expenses (% of total expenses) of Subsidies and Transfers in 1999?
Your answer should be very brief. -2.16. What is the difference between the Expenses (% of total expenses) in Goods and services in 1994 and the Expenses (% of total expenses) in Other expenses in 1999?
Give a very brief answer. 54.75. What is the difference between the Expenses (% of total expenses) in Subsidies and Transfers in 1994 and the Expenses (% of total expenses) in Other expenses in 1999?
Give a very brief answer. 28.57. What is the difference between the Expenses (% of total expenses) in Compensation of employees in 1995 and the Expenses (% of total expenses) in Goods and services in 1996?
Offer a very short reply. -19.41. What is the difference between the Expenses (% of total expenses) in Compensation of employees in 1995 and the Expenses (% of total expenses) in Subsidies and Transfers in 1996?
Offer a terse response. -58.84. What is the difference between the Expenses (% of total expenses) in Compensation of employees in 1995 and the Expenses (% of total expenses) in Other expenses in 1996?
Your answer should be compact. 0.62. What is the difference between the Expenses (% of total expenses) in Goods and services in 1995 and the Expenses (% of total expenses) in Subsidies and Transfers in 1996?
Ensure brevity in your answer.  -24.27. What is the difference between the Expenses (% of total expenses) of Goods and services in 1995 and the Expenses (% of total expenses) of Other expenses in 1996?
Give a very brief answer. 35.19. What is the difference between the Expenses (% of total expenses) of Subsidies and Transfers in 1995 and the Expenses (% of total expenses) of Other expenses in 1996?
Offer a terse response. 50.97. What is the difference between the Expenses (% of total expenses) of Compensation of employees in 1995 and the Expenses (% of total expenses) of Goods and services in 1997?
Provide a succinct answer. -17.87. What is the difference between the Expenses (% of total expenses) in Compensation of employees in 1995 and the Expenses (% of total expenses) in Subsidies and Transfers in 1997?
Provide a succinct answer. -60.89. What is the difference between the Expenses (% of total expenses) in Compensation of employees in 1995 and the Expenses (% of total expenses) in Other expenses in 1997?
Keep it short and to the point. 1.93. What is the difference between the Expenses (% of total expenses) of Goods and services in 1995 and the Expenses (% of total expenses) of Subsidies and Transfers in 1997?
Make the answer very short. -26.32. What is the difference between the Expenses (% of total expenses) in Goods and services in 1995 and the Expenses (% of total expenses) in Other expenses in 1997?
Keep it short and to the point. 36.5. What is the difference between the Expenses (% of total expenses) of Subsidies and Transfers in 1995 and the Expenses (% of total expenses) of Other expenses in 1997?
Provide a succinct answer. 52.28. What is the difference between the Expenses (% of total expenses) in Compensation of employees in 1995 and the Expenses (% of total expenses) in Goods and services in 1998?
Offer a very short reply. -14.73. What is the difference between the Expenses (% of total expenses) of Compensation of employees in 1995 and the Expenses (% of total expenses) of Subsidies and Transfers in 1998?
Offer a terse response. -62.76. What is the difference between the Expenses (% of total expenses) of Compensation of employees in 1995 and the Expenses (% of total expenses) of Other expenses in 1998?
Provide a succinct answer. 1.76. What is the difference between the Expenses (% of total expenses) in Goods and services in 1995 and the Expenses (% of total expenses) in Subsidies and Transfers in 1998?
Offer a very short reply. -28.19. What is the difference between the Expenses (% of total expenses) of Goods and services in 1995 and the Expenses (% of total expenses) of Other expenses in 1998?
Your answer should be very brief. 36.32. What is the difference between the Expenses (% of total expenses) of Subsidies and Transfers in 1995 and the Expenses (% of total expenses) of Other expenses in 1998?
Your answer should be compact. 52.11. What is the difference between the Expenses (% of total expenses) of Compensation of employees in 1995 and the Expenses (% of total expenses) of Goods and services in 1999?
Your answer should be compact. -10.29. What is the difference between the Expenses (% of total expenses) of Compensation of employees in 1995 and the Expenses (% of total expenses) of Subsidies and Transfers in 1999?
Make the answer very short. -58.44. What is the difference between the Expenses (% of total expenses) of Compensation of employees in 1995 and the Expenses (% of total expenses) of Other expenses in 1999?
Provide a succinct answer. -1.52. What is the difference between the Expenses (% of total expenses) of Goods and services in 1995 and the Expenses (% of total expenses) of Subsidies and Transfers in 1999?
Provide a short and direct response. -23.87. What is the difference between the Expenses (% of total expenses) of Goods and services in 1995 and the Expenses (% of total expenses) of Other expenses in 1999?
Provide a succinct answer. 33.04. What is the difference between the Expenses (% of total expenses) in Subsidies and Transfers in 1995 and the Expenses (% of total expenses) in Other expenses in 1999?
Provide a succinct answer. 48.83. What is the difference between the Expenses (% of total expenses) of Compensation of employees in 1996 and the Expenses (% of total expenses) of Goods and services in 1997?
Your response must be concise. -12.69. What is the difference between the Expenses (% of total expenses) of Compensation of employees in 1996 and the Expenses (% of total expenses) of Subsidies and Transfers in 1997?
Your answer should be compact. -55.71. What is the difference between the Expenses (% of total expenses) in Compensation of employees in 1996 and the Expenses (% of total expenses) in Other expenses in 1997?
Give a very brief answer. 7.11. What is the difference between the Expenses (% of total expenses) in Goods and services in 1996 and the Expenses (% of total expenses) in Subsidies and Transfers in 1997?
Keep it short and to the point. -41.48. What is the difference between the Expenses (% of total expenses) of Goods and services in 1996 and the Expenses (% of total expenses) of Other expenses in 1997?
Your answer should be compact. 21.34. What is the difference between the Expenses (% of total expenses) of Subsidies and Transfers in 1996 and the Expenses (% of total expenses) of Other expenses in 1997?
Make the answer very short. 60.77. What is the difference between the Expenses (% of total expenses) in Compensation of employees in 1996 and the Expenses (% of total expenses) in Goods and services in 1998?
Ensure brevity in your answer.  -9.55. What is the difference between the Expenses (% of total expenses) of Compensation of employees in 1996 and the Expenses (% of total expenses) of Subsidies and Transfers in 1998?
Offer a terse response. -57.58. What is the difference between the Expenses (% of total expenses) in Compensation of employees in 1996 and the Expenses (% of total expenses) in Other expenses in 1998?
Provide a succinct answer. 6.94. What is the difference between the Expenses (% of total expenses) of Goods and services in 1996 and the Expenses (% of total expenses) of Subsidies and Transfers in 1998?
Provide a succinct answer. -43.34. What is the difference between the Expenses (% of total expenses) of Goods and services in 1996 and the Expenses (% of total expenses) of Other expenses in 1998?
Keep it short and to the point. 21.17. What is the difference between the Expenses (% of total expenses) of Subsidies and Transfers in 1996 and the Expenses (% of total expenses) of Other expenses in 1998?
Your answer should be compact. 60.6. What is the difference between the Expenses (% of total expenses) in Compensation of employees in 1996 and the Expenses (% of total expenses) in Goods and services in 1999?
Your answer should be very brief. -5.11. What is the difference between the Expenses (% of total expenses) of Compensation of employees in 1996 and the Expenses (% of total expenses) of Subsidies and Transfers in 1999?
Give a very brief answer. -53.26. What is the difference between the Expenses (% of total expenses) in Compensation of employees in 1996 and the Expenses (% of total expenses) in Other expenses in 1999?
Your response must be concise. 3.66. What is the difference between the Expenses (% of total expenses) in Goods and services in 1996 and the Expenses (% of total expenses) in Subsidies and Transfers in 1999?
Provide a short and direct response. -39.02. What is the difference between the Expenses (% of total expenses) in Goods and services in 1996 and the Expenses (% of total expenses) in Other expenses in 1999?
Keep it short and to the point. 17.89. What is the difference between the Expenses (% of total expenses) in Subsidies and Transfers in 1996 and the Expenses (% of total expenses) in Other expenses in 1999?
Provide a short and direct response. 57.32. What is the difference between the Expenses (% of total expenses) of Compensation of employees in 1997 and the Expenses (% of total expenses) of Goods and services in 1998?
Your answer should be compact. -10.49. What is the difference between the Expenses (% of total expenses) in Compensation of employees in 1997 and the Expenses (% of total expenses) in Subsidies and Transfers in 1998?
Make the answer very short. -58.51. What is the difference between the Expenses (% of total expenses) in Compensation of employees in 1997 and the Expenses (% of total expenses) in Other expenses in 1998?
Your response must be concise. 6. What is the difference between the Expenses (% of total expenses) in Goods and services in 1997 and the Expenses (% of total expenses) in Subsidies and Transfers in 1998?
Offer a terse response. -44.89. What is the difference between the Expenses (% of total expenses) in Goods and services in 1997 and the Expenses (% of total expenses) in Other expenses in 1998?
Ensure brevity in your answer.  19.62. What is the difference between the Expenses (% of total expenses) of Subsidies and Transfers in 1997 and the Expenses (% of total expenses) of Other expenses in 1998?
Your answer should be very brief. 62.65. What is the difference between the Expenses (% of total expenses) in Compensation of employees in 1997 and the Expenses (% of total expenses) in Goods and services in 1999?
Ensure brevity in your answer.  -6.05. What is the difference between the Expenses (% of total expenses) of Compensation of employees in 1997 and the Expenses (% of total expenses) of Subsidies and Transfers in 1999?
Provide a succinct answer. -54.19. What is the difference between the Expenses (% of total expenses) of Compensation of employees in 1997 and the Expenses (% of total expenses) of Other expenses in 1999?
Your answer should be very brief. 2.72. What is the difference between the Expenses (% of total expenses) of Goods and services in 1997 and the Expenses (% of total expenses) of Subsidies and Transfers in 1999?
Make the answer very short. -40.57. What is the difference between the Expenses (% of total expenses) of Goods and services in 1997 and the Expenses (% of total expenses) of Other expenses in 1999?
Ensure brevity in your answer.  16.34. What is the difference between the Expenses (% of total expenses) of Subsidies and Transfers in 1997 and the Expenses (% of total expenses) of Other expenses in 1999?
Make the answer very short. 59.37. What is the difference between the Expenses (% of total expenses) in Compensation of employees in 1998 and the Expenses (% of total expenses) in Goods and services in 1999?
Provide a succinct answer. -4.83. What is the difference between the Expenses (% of total expenses) in Compensation of employees in 1998 and the Expenses (% of total expenses) in Subsidies and Transfers in 1999?
Your response must be concise. -52.98. What is the difference between the Expenses (% of total expenses) in Compensation of employees in 1998 and the Expenses (% of total expenses) in Other expenses in 1999?
Give a very brief answer. 3.93. What is the difference between the Expenses (% of total expenses) of Goods and services in 1998 and the Expenses (% of total expenses) of Subsidies and Transfers in 1999?
Ensure brevity in your answer.  -43.7. What is the difference between the Expenses (% of total expenses) in Goods and services in 1998 and the Expenses (% of total expenses) in Other expenses in 1999?
Keep it short and to the point. 13.21. What is the difference between the Expenses (% of total expenses) in Subsidies and Transfers in 1998 and the Expenses (% of total expenses) in Other expenses in 1999?
Give a very brief answer. 61.23. What is the average Expenses (% of total expenses) in Compensation of employees per year?
Give a very brief answer. 6.62. What is the average Expenses (% of total expenses) in Goods and services per year?
Your answer should be compact. 34.59. What is the average Expenses (% of total expenses) in Subsidies and Transfers per year?
Your answer should be very brief. 55.5. What is the average Expenses (% of total expenses) of Other expenses per year?
Make the answer very short. 3.36. In the year 1992, what is the difference between the Expenses (% of total expenses) in Compensation of employees and Expenses (% of total expenses) in Goods and services?
Offer a very short reply. -38.49. In the year 1992, what is the difference between the Expenses (% of total expenses) in Compensation of employees and Expenses (% of total expenses) in Subsidies and Transfers?
Make the answer very short. -52.23. In the year 1992, what is the difference between the Expenses (% of total expenses) in Compensation of employees and Expenses (% of total expenses) in Other expenses?
Give a very brief answer. 2.4. In the year 1992, what is the difference between the Expenses (% of total expenses) of Goods and services and Expenses (% of total expenses) of Subsidies and Transfers?
Provide a short and direct response. -13.75. In the year 1992, what is the difference between the Expenses (% of total expenses) in Goods and services and Expenses (% of total expenses) in Other expenses?
Your answer should be compact. 40.88. In the year 1992, what is the difference between the Expenses (% of total expenses) of Subsidies and Transfers and Expenses (% of total expenses) of Other expenses?
Make the answer very short. 54.63. In the year 1993, what is the difference between the Expenses (% of total expenses) in Compensation of employees and Expenses (% of total expenses) in Goods and services?
Ensure brevity in your answer.  -50.03. In the year 1993, what is the difference between the Expenses (% of total expenses) in Compensation of employees and Expenses (% of total expenses) in Subsidies and Transfers?
Your answer should be compact. -35.34. In the year 1993, what is the difference between the Expenses (% of total expenses) in Compensation of employees and Expenses (% of total expenses) in Other expenses?
Your answer should be compact. 3.79. In the year 1993, what is the difference between the Expenses (% of total expenses) of Goods and services and Expenses (% of total expenses) of Subsidies and Transfers?
Make the answer very short. 14.68. In the year 1993, what is the difference between the Expenses (% of total expenses) in Goods and services and Expenses (% of total expenses) in Other expenses?
Your answer should be very brief. 53.82. In the year 1993, what is the difference between the Expenses (% of total expenses) of Subsidies and Transfers and Expenses (% of total expenses) of Other expenses?
Your response must be concise. 39.13. In the year 1994, what is the difference between the Expenses (% of total expenses) in Compensation of employees and Expenses (% of total expenses) in Goods and services?
Offer a terse response. -57.64. In the year 1994, what is the difference between the Expenses (% of total expenses) in Compensation of employees and Expenses (% of total expenses) in Subsidies and Transfers?
Offer a very short reply. -31.46. In the year 1994, what is the difference between the Expenses (% of total expenses) in Compensation of employees and Expenses (% of total expenses) in Other expenses?
Keep it short and to the point. 3.38. In the year 1994, what is the difference between the Expenses (% of total expenses) in Goods and services and Expenses (% of total expenses) in Subsidies and Transfers?
Your answer should be compact. 26.18. In the year 1994, what is the difference between the Expenses (% of total expenses) of Goods and services and Expenses (% of total expenses) of Other expenses?
Make the answer very short. 61.03. In the year 1994, what is the difference between the Expenses (% of total expenses) in Subsidies and Transfers and Expenses (% of total expenses) in Other expenses?
Your answer should be compact. 34.84. In the year 1995, what is the difference between the Expenses (% of total expenses) in Compensation of employees and Expenses (% of total expenses) in Goods and services?
Offer a terse response. -34.57. In the year 1995, what is the difference between the Expenses (% of total expenses) in Compensation of employees and Expenses (% of total expenses) in Subsidies and Transfers?
Keep it short and to the point. -50.35. In the year 1995, what is the difference between the Expenses (% of total expenses) of Compensation of employees and Expenses (% of total expenses) of Other expenses?
Keep it short and to the point. -5.5. In the year 1995, what is the difference between the Expenses (% of total expenses) in Goods and services and Expenses (% of total expenses) in Subsidies and Transfers?
Make the answer very short. -15.78. In the year 1995, what is the difference between the Expenses (% of total expenses) of Goods and services and Expenses (% of total expenses) of Other expenses?
Provide a succinct answer. 29.07. In the year 1995, what is the difference between the Expenses (% of total expenses) of Subsidies and Transfers and Expenses (% of total expenses) of Other expenses?
Ensure brevity in your answer.  44.85. In the year 1996, what is the difference between the Expenses (% of total expenses) in Compensation of employees and Expenses (% of total expenses) in Goods and services?
Ensure brevity in your answer.  -14.23. In the year 1996, what is the difference between the Expenses (% of total expenses) in Compensation of employees and Expenses (% of total expenses) in Subsidies and Transfers?
Your answer should be compact. -53.66. In the year 1996, what is the difference between the Expenses (% of total expenses) of Compensation of employees and Expenses (% of total expenses) of Other expenses?
Your answer should be compact. 5.8. In the year 1996, what is the difference between the Expenses (% of total expenses) in Goods and services and Expenses (% of total expenses) in Subsidies and Transfers?
Keep it short and to the point. -39.43. In the year 1996, what is the difference between the Expenses (% of total expenses) of Goods and services and Expenses (% of total expenses) of Other expenses?
Ensure brevity in your answer.  20.03. In the year 1996, what is the difference between the Expenses (% of total expenses) in Subsidies and Transfers and Expenses (% of total expenses) in Other expenses?
Your response must be concise. 59.46. In the year 1997, what is the difference between the Expenses (% of total expenses) in Compensation of employees and Expenses (% of total expenses) in Goods and services?
Keep it short and to the point. -13.62. In the year 1997, what is the difference between the Expenses (% of total expenses) of Compensation of employees and Expenses (% of total expenses) of Subsidies and Transfers?
Offer a very short reply. -56.65. In the year 1997, what is the difference between the Expenses (% of total expenses) of Compensation of employees and Expenses (% of total expenses) of Other expenses?
Keep it short and to the point. 6.17. In the year 1997, what is the difference between the Expenses (% of total expenses) of Goods and services and Expenses (% of total expenses) of Subsidies and Transfers?
Offer a terse response. -43.03. In the year 1997, what is the difference between the Expenses (% of total expenses) in Goods and services and Expenses (% of total expenses) in Other expenses?
Your response must be concise. 19.79. In the year 1997, what is the difference between the Expenses (% of total expenses) in Subsidies and Transfers and Expenses (% of total expenses) in Other expenses?
Keep it short and to the point. 62.82. In the year 1998, what is the difference between the Expenses (% of total expenses) of Compensation of employees and Expenses (% of total expenses) of Goods and services?
Offer a terse response. -9.28. In the year 1998, what is the difference between the Expenses (% of total expenses) in Compensation of employees and Expenses (% of total expenses) in Subsidies and Transfers?
Provide a short and direct response. -57.3. In the year 1998, what is the difference between the Expenses (% of total expenses) in Compensation of employees and Expenses (% of total expenses) in Other expenses?
Your response must be concise. 7.21. In the year 1998, what is the difference between the Expenses (% of total expenses) of Goods and services and Expenses (% of total expenses) of Subsidies and Transfers?
Make the answer very short. -48.02. In the year 1998, what is the difference between the Expenses (% of total expenses) of Goods and services and Expenses (% of total expenses) of Other expenses?
Offer a very short reply. 16.49. In the year 1998, what is the difference between the Expenses (% of total expenses) in Subsidies and Transfers and Expenses (% of total expenses) in Other expenses?
Provide a succinct answer. 64.51. In the year 1999, what is the difference between the Expenses (% of total expenses) of Compensation of employees and Expenses (% of total expenses) of Goods and services?
Your response must be concise. -5.88. In the year 1999, what is the difference between the Expenses (% of total expenses) in Compensation of employees and Expenses (% of total expenses) in Subsidies and Transfers?
Your response must be concise. -54.02. In the year 1999, what is the difference between the Expenses (% of total expenses) in Compensation of employees and Expenses (% of total expenses) in Other expenses?
Your response must be concise. 2.89. In the year 1999, what is the difference between the Expenses (% of total expenses) of Goods and services and Expenses (% of total expenses) of Subsidies and Transfers?
Ensure brevity in your answer.  -48.15. In the year 1999, what is the difference between the Expenses (% of total expenses) in Goods and services and Expenses (% of total expenses) in Other expenses?
Give a very brief answer. 8.77. In the year 1999, what is the difference between the Expenses (% of total expenses) of Subsidies and Transfers and Expenses (% of total expenses) of Other expenses?
Give a very brief answer. 56.91. What is the ratio of the Expenses (% of total expenses) of Compensation of employees in 1992 to that in 1993?
Provide a succinct answer. 0.58. What is the ratio of the Expenses (% of total expenses) of Goods and services in 1992 to that in 1993?
Your answer should be compact. 0.75. What is the ratio of the Expenses (% of total expenses) in Subsidies and Transfers in 1992 to that in 1993?
Keep it short and to the point. 1.38. What is the ratio of the Expenses (% of total expenses) of Other expenses in 1992 to that in 1993?
Your answer should be compact. 0.03. What is the ratio of the Expenses (% of total expenses) in Compensation of employees in 1992 to that in 1994?
Keep it short and to the point. 0.71. What is the ratio of the Expenses (% of total expenses) in Goods and services in 1992 to that in 1994?
Offer a very short reply. 0.67. What is the ratio of the Expenses (% of total expenses) in Subsidies and Transfers in 1992 to that in 1994?
Ensure brevity in your answer.  1.57. What is the ratio of the Expenses (% of total expenses) in Other expenses in 1992 to that in 1994?
Your answer should be very brief. 2.25. What is the ratio of the Expenses (% of total expenses) of Compensation of employees in 1992 to that in 1995?
Your answer should be very brief. 0.51. What is the ratio of the Expenses (% of total expenses) in Goods and services in 1992 to that in 1995?
Provide a succinct answer. 1.04. What is the ratio of the Expenses (% of total expenses) of Other expenses in 1992 to that in 1995?
Ensure brevity in your answer.  0. What is the ratio of the Expenses (% of total expenses) in Compensation of employees in 1992 to that in 1996?
Provide a succinct answer. 0.24. What is the ratio of the Expenses (% of total expenses) of Goods and services in 1992 to that in 1996?
Ensure brevity in your answer.  1.69. What is the ratio of the Expenses (% of total expenses) of Subsidies and Transfers in 1992 to that in 1996?
Your answer should be very brief. 0.86. What is the ratio of the Expenses (% of total expenses) in Other expenses in 1992 to that in 1996?
Your answer should be compact. 0. What is the ratio of the Expenses (% of total expenses) in Compensation of employees in 1992 to that in 1997?
Provide a short and direct response. 0.27. What is the ratio of the Expenses (% of total expenses) in Goods and services in 1992 to that in 1997?
Ensure brevity in your answer.  1.81. What is the ratio of the Expenses (% of total expenses) in Subsidies and Transfers in 1992 to that in 1997?
Offer a very short reply. 0.83. What is the ratio of the Expenses (% of total expenses) in Other expenses in 1992 to that in 1997?
Your answer should be compact. 0. What is the ratio of the Expenses (% of total expenses) of Compensation of employees in 1992 to that in 1998?
Ensure brevity in your answer.  0.24. What is the ratio of the Expenses (% of total expenses) in Goods and services in 1992 to that in 1998?
Offer a very short reply. 2.1. What is the ratio of the Expenses (% of total expenses) of Subsidies and Transfers in 1992 to that in 1998?
Provide a succinct answer. 0.81. What is the ratio of the Expenses (% of total expenses) of Other expenses in 1992 to that in 1998?
Give a very brief answer. 0. What is the ratio of the Expenses (% of total expenses) of Compensation of employees in 1992 to that in 1999?
Ensure brevity in your answer.  0.26. What is the ratio of the Expenses (% of total expenses) of Goods and services in 1992 to that in 1999?
Keep it short and to the point. 2.72. What is the ratio of the Expenses (% of total expenses) of Subsidies and Transfers in 1992 to that in 1999?
Give a very brief answer. 0.86. What is the ratio of the Expenses (% of total expenses) of Other expenses in 1992 to that in 1999?
Offer a very short reply. 0. What is the ratio of the Expenses (% of total expenses) of Compensation of employees in 1993 to that in 1994?
Your answer should be compact. 1.23. What is the ratio of the Expenses (% of total expenses) in Goods and services in 1993 to that in 1994?
Keep it short and to the point. 0.89. What is the ratio of the Expenses (% of total expenses) in Subsidies and Transfers in 1993 to that in 1994?
Your answer should be very brief. 1.13. What is the ratio of the Expenses (% of total expenses) of Other expenses in 1993 to that in 1994?
Your response must be concise. 88.41. What is the ratio of the Expenses (% of total expenses) in Compensation of employees in 1993 to that in 1995?
Keep it short and to the point. 0.88. What is the ratio of the Expenses (% of total expenses) of Goods and services in 1993 to that in 1995?
Your response must be concise. 1.38. What is the ratio of the Expenses (% of total expenses) of Subsidies and Transfers in 1993 to that in 1995?
Ensure brevity in your answer.  0.72. What is the ratio of the Expenses (% of total expenses) in Other expenses in 1993 to that in 1995?
Offer a very short reply. 0.04. What is the ratio of the Expenses (% of total expenses) of Compensation of employees in 1993 to that in 1996?
Give a very brief answer. 0.42. What is the ratio of the Expenses (% of total expenses) of Goods and services in 1993 to that in 1996?
Your answer should be very brief. 2.24. What is the ratio of the Expenses (% of total expenses) in Subsidies and Transfers in 1993 to that in 1996?
Offer a terse response. 0.62. What is the ratio of the Expenses (% of total expenses) in Other expenses in 1993 to that in 1996?
Offer a terse response. 0.09. What is the ratio of the Expenses (% of total expenses) of Compensation of employees in 1993 to that in 1997?
Your answer should be compact. 0.46. What is the ratio of the Expenses (% of total expenses) in Goods and services in 1993 to that in 1997?
Keep it short and to the point. 2.4. What is the ratio of the Expenses (% of total expenses) in Subsidies and Transfers in 1993 to that in 1997?
Provide a succinct answer. 0.6. What is the ratio of the Expenses (% of total expenses) of Other expenses in 1993 to that in 1997?
Your answer should be very brief. 0.13. What is the ratio of the Expenses (% of total expenses) of Compensation of employees in 1993 to that in 1998?
Your answer should be very brief. 0.41. What is the ratio of the Expenses (% of total expenses) in Goods and services in 1993 to that in 1998?
Provide a short and direct response. 2.78. What is the ratio of the Expenses (% of total expenses) of Subsidies and Transfers in 1993 to that in 1998?
Keep it short and to the point. 0.59. What is the ratio of the Expenses (% of total expenses) in Other expenses in 1993 to that in 1998?
Provide a succinct answer. 0.12. What is the ratio of the Expenses (% of total expenses) in Compensation of employees in 1993 to that in 1999?
Give a very brief answer. 0.45. What is the ratio of the Expenses (% of total expenses) in Goods and services in 1993 to that in 1999?
Give a very brief answer. 3.6. What is the ratio of the Expenses (% of total expenses) in Subsidies and Transfers in 1993 to that in 1999?
Make the answer very short. 0.63. What is the ratio of the Expenses (% of total expenses) in Other expenses in 1993 to that in 1999?
Your answer should be very brief. 0.06. What is the ratio of the Expenses (% of total expenses) in Compensation of employees in 1994 to that in 1995?
Make the answer very short. 0.71. What is the ratio of the Expenses (% of total expenses) of Goods and services in 1994 to that in 1995?
Keep it short and to the point. 1.55. What is the ratio of the Expenses (% of total expenses) of Subsidies and Transfers in 1994 to that in 1995?
Your answer should be very brief. 0.63. What is the ratio of the Expenses (% of total expenses) of Other expenses in 1994 to that in 1995?
Your answer should be very brief. 0. What is the ratio of the Expenses (% of total expenses) of Compensation of employees in 1994 to that in 1996?
Offer a very short reply. 0.34. What is the ratio of the Expenses (% of total expenses) in Goods and services in 1994 to that in 1996?
Give a very brief answer. 2.53. What is the ratio of the Expenses (% of total expenses) of Subsidies and Transfers in 1994 to that in 1996?
Offer a very short reply. 0.55. What is the ratio of the Expenses (% of total expenses) in Other expenses in 1994 to that in 1996?
Provide a succinct answer. 0. What is the ratio of the Expenses (% of total expenses) in Compensation of employees in 1994 to that in 1997?
Ensure brevity in your answer.  0.38. What is the ratio of the Expenses (% of total expenses) of Goods and services in 1994 to that in 1997?
Offer a very short reply. 2.7. What is the ratio of the Expenses (% of total expenses) in Subsidies and Transfers in 1994 to that in 1997?
Ensure brevity in your answer.  0.53. What is the ratio of the Expenses (% of total expenses) in Other expenses in 1994 to that in 1997?
Your answer should be compact. 0. What is the ratio of the Expenses (% of total expenses) in Compensation of employees in 1994 to that in 1998?
Offer a terse response. 0.33. What is the ratio of the Expenses (% of total expenses) of Goods and services in 1994 to that in 1998?
Provide a short and direct response. 3.13. What is the ratio of the Expenses (% of total expenses) in Subsidies and Transfers in 1994 to that in 1998?
Keep it short and to the point. 0.52. What is the ratio of the Expenses (% of total expenses) of Other expenses in 1994 to that in 1998?
Offer a very short reply. 0. What is the ratio of the Expenses (% of total expenses) of Compensation of employees in 1994 to that in 1999?
Keep it short and to the point. 0.37. What is the ratio of the Expenses (% of total expenses) in Goods and services in 1994 to that in 1999?
Make the answer very short. 4.06. What is the ratio of the Expenses (% of total expenses) in Subsidies and Transfers in 1994 to that in 1999?
Your answer should be very brief. 0.55. What is the ratio of the Expenses (% of total expenses) of Other expenses in 1994 to that in 1999?
Ensure brevity in your answer.  0. What is the ratio of the Expenses (% of total expenses) of Compensation of employees in 1995 to that in 1996?
Ensure brevity in your answer.  0.48. What is the ratio of the Expenses (% of total expenses) of Goods and services in 1995 to that in 1996?
Your response must be concise. 1.63. What is the ratio of the Expenses (% of total expenses) of Subsidies and Transfers in 1995 to that in 1996?
Offer a terse response. 0.87. What is the ratio of the Expenses (% of total expenses) of Other expenses in 1995 to that in 1996?
Keep it short and to the point. 2.48. What is the ratio of the Expenses (% of total expenses) in Compensation of employees in 1995 to that in 1997?
Make the answer very short. 0.53. What is the ratio of the Expenses (% of total expenses) in Goods and services in 1995 to that in 1997?
Your answer should be compact. 1.74. What is the ratio of the Expenses (% of total expenses) in Subsidies and Transfers in 1995 to that in 1997?
Ensure brevity in your answer.  0.84. What is the ratio of the Expenses (% of total expenses) of Other expenses in 1995 to that in 1997?
Offer a very short reply. 3.63. What is the ratio of the Expenses (% of total expenses) in Compensation of employees in 1995 to that in 1998?
Your answer should be compact. 0.47. What is the ratio of the Expenses (% of total expenses) in Goods and services in 1995 to that in 1998?
Your response must be concise. 2.02. What is the ratio of the Expenses (% of total expenses) of Subsidies and Transfers in 1995 to that in 1998?
Make the answer very short. 0.82. What is the ratio of the Expenses (% of total expenses) of Other expenses in 1995 to that in 1998?
Provide a succinct answer. 3.42. What is the ratio of the Expenses (% of total expenses) in Compensation of employees in 1995 to that in 1999?
Give a very brief answer. 0.52. What is the ratio of the Expenses (% of total expenses) in Goods and services in 1995 to that in 1999?
Give a very brief answer. 2.61. What is the ratio of the Expenses (% of total expenses) in Subsidies and Transfers in 1995 to that in 1999?
Your answer should be compact. 0.87. What is the ratio of the Expenses (% of total expenses) of Other expenses in 1995 to that in 1999?
Your response must be concise. 1.63. What is the ratio of the Expenses (% of total expenses) of Compensation of employees in 1996 to that in 1997?
Your answer should be compact. 1.1. What is the ratio of the Expenses (% of total expenses) of Goods and services in 1996 to that in 1997?
Provide a short and direct response. 1.07. What is the ratio of the Expenses (% of total expenses) in Subsidies and Transfers in 1996 to that in 1997?
Offer a very short reply. 0.97. What is the ratio of the Expenses (% of total expenses) in Other expenses in 1996 to that in 1997?
Your answer should be very brief. 1.47. What is the ratio of the Expenses (% of total expenses) in Compensation of employees in 1996 to that in 1998?
Offer a terse response. 0.97. What is the ratio of the Expenses (% of total expenses) in Goods and services in 1996 to that in 1998?
Provide a succinct answer. 1.24. What is the ratio of the Expenses (% of total expenses) in Subsidies and Transfers in 1996 to that in 1998?
Offer a terse response. 0.94. What is the ratio of the Expenses (% of total expenses) of Other expenses in 1996 to that in 1998?
Offer a terse response. 1.38. What is the ratio of the Expenses (% of total expenses) of Compensation of employees in 1996 to that in 1999?
Offer a very short reply. 1.08. What is the ratio of the Expenses (% of total expenses) in Goods and services in 1996 to that in 1999?
Your answer should be very brief. 1.61. What is the ratio of the Expenses (% of total expenses) of Subsidies and Transfers in 1996 to that in 1999?
Your response must be concise. 1.01. What is the ratio of the Expenses (% of total expenses) in Other expenses in 1996 to that in 1999?
Your answer should be compact. 0.66. What is the ratio of the Expenses (% of total expenses) of Compensation of employees in 1997 to that in 1998?
Make the answer very short. 0.88. What is the ratio of the Expenses (% of total expenses) in Goods and services in 1997 to that in 1998?
Give a very brief answer. 1.16. What is the ratio of the Expenses (% of total expenses) in Subsidies and Transfers in 1997 to that in 1998?
Keep it short and to the point. 0.97. What is the ratio of the Expenses (% of total expenses) in Other expenses in 1997 to that in 1998?
Provide a succinct answer. 0.94. What is the ratio of the Expenses (% of total expenses) in Compensation of employees in 1997 to that in 1999?
Offer a very short reply. 0.98. What is the ratio of the Expenses (% of total expenses) of Goods and services in 1997 to that in 1999?
Offer a very short reply. 1.5. What is the ratio of the Expenses (% of total expenses) of Subsidies and Transfers in 1997 to that in 1999?
Provide a succinct answer. 1.04. What is the ratio of the Expenses (% of total expenses) in Other expenses in 1997 to that in 1999?
Provide a succinct answer. 0.45. What is the ratio of the Expenses (% of total expenses) in Compensation of employees in 1998 to that in 1999?
Offer a very short reply. 1.11. What is the ratio of the Expenses (% of total expenses) of Goods and services in 1998 to that in 1999?
Keep it short and to the point. 1.3. What is the ratio of the Expenses (% of total expenses) of Subsidies and Transfers in 1998 to that in 1999?
Offer a terse response. 1.07. What is the ratio of the Expenses (% of total expenses) in Other expenses in 1998 to that in 1999?
Provide a succinct answer. 0.48. What is the difference between the highest and the second highest Expenses (% of total expenses) in Compensation of employees?
Provide a short and direct response. 0.28. What is the difference between the highest and the second highest Expenses (% of total expenses) of Goods and services?
Your answer should be compact. 6.84. What is the difference between the highest and the second highest Expenses (% of total expenses) in Subsidies and Transfers?
Your answer should be very brief. 1.86. What is the difference between the highest and the second highest Expenses (% of total expenses) in Other expenses?
Give a very brief answer. 3.97. What is the difference between the highest and the lowest Expenses (% of total expenses) in Compensation of employees?
Make the answer very short. 7.8. What is the difference between the highest and the lowest Expenses (% of total expenses) of Goods and services?
Offer a very short reply. 45.99. What is the difference between the highest and the lowest Expenses (% of total expenses) of Subsidies and Transfers?
Offer a terse response. 32.66. What is the difference between the highest and the lowest Expenses (% of total expenses) of Other expenses?
Provide a short and direct response. 10.24. 